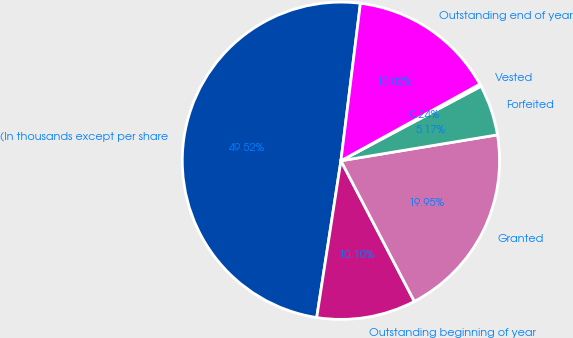Convert chart to OTSL. <chart><loc_0><loc_0><loc_500><loc_500><pie_chart><fcel>(In thousands except per share<fcel>Outstanding beginning of year<fcel>Granted<fcel>Forfeited<fcel>Vested<fcel>Outstanding end of year<nl><fcel>49.52%<fcel>10.1%<fcel>19.95%<fcel>5.17%<fcel>0.24%<fcel>15.02%<nl></chart> 